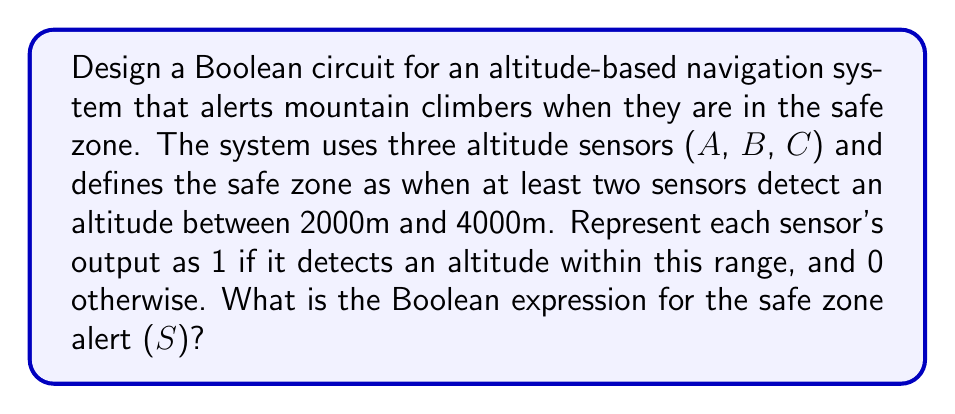Can you answer this question? Let's approach this step-by-step:

1) We need the alert to activate when at least two sensors detect the safe altitude range. This is a majority function.

2) We can represent this using the following logic:
   - S should be 1 when (A AND B) OR (A AND C) OR (B AND C) are true.

3) In Boolean algebra, this can be written as:
   $$S = AB + AC + BC$$

4) We can also represent this using the Sum of Products (SOP) form:
   $$S = A \cdot B + A \cdot C + B \cdot C$$

5) This can be implemented using AND gates and OR gates:
   - Three AND gates for AB, AC, and BC
   - One OR gate to combine the outputs of the AND gates

6) The circuit diagram would look like this:

[asy]
unitsize(1cm);

pair A = (0,4), B = (0,2), C = (0,0);
pair AND1 = (2,3), AND2 = (2,1), AND3 = (2,-1);
pair OR = (4,1);
pair S = (6,1);

draw(A--AND1--OR--S);
draw(B--AND1);
draw(A--AND2);
draw(C--AND2--OR);
draw(B--AND3--OR);
draw(C--AND3);

label("A", A, W);
label("B", B, W);
label("C", C, W);
label("S", S, E);

label("&", AND1, E);
label("&", AND2, E);
label("&", AND3, E);
label("≥1", OR, E);
[/asy]

This circuit implements the Boolean function we derived, providing an alert when the mountain climber is in the safe altitude zone according to at least two sensors.
Answer: $$S = AB + AC + BC$$ 